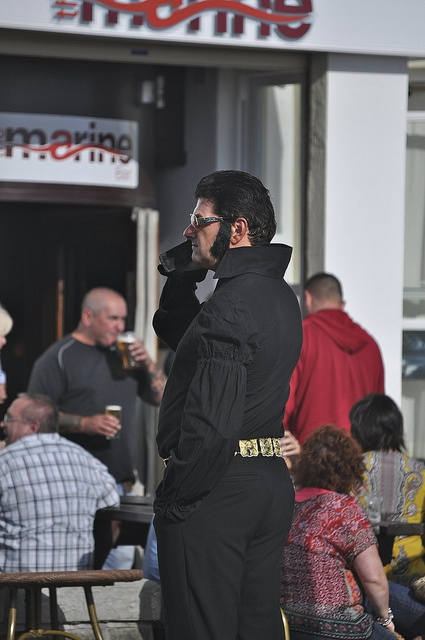Describe the objects in this image and their specific colors. I can see people in darkgray, black, and gray tones, people in darkgray, black, gray, brown, and maroon tones, people in darkgray, gray, and black tones, people in darkgray, black, and gray tones, and people in darkgray, brown, maroon, and gray tones in this image. 